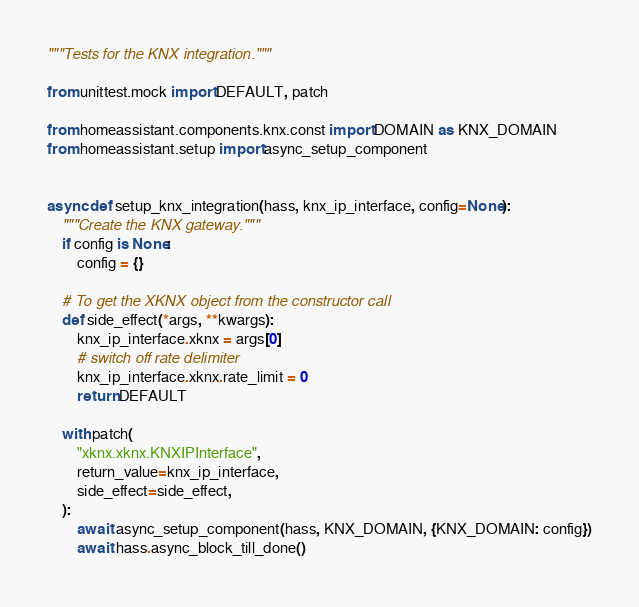Convert code to text. <code><loc_0><loc_0><loc_500><loc_500><_Python_>"""Tests for the KNX integration."""

from unittest.mock import DEFAULT, patch

from homeassistant.components.knx.const import DOMAIN as KNX_DOMAIN
from homeassistant.setup import async_setup_component


async def setup_knx_integration(hass, knx_ip_interface, config=None):
    """Create the KNX gateway."""
    if config is None:
        config = {}

    # To get the XKNX object from the constructor call
    def side_effect(*args, **kwargs):
        knx_ip_interface.xknx = args[0]
        # switch off rate delimiter
        knx_ip_interface.xknx.rate_limit = 0
        return DEFAULT

    with patch(
        "xknx.xknx.KNXIPInterface",
        return_value=knx_ip_interface,
        side_effect=side_effect,
    ):
        await async_setup_component(hass, KNX_DOMAIN, {KNX_DOMAIN: config})
        await hass.async_block_till_done()
</code> 